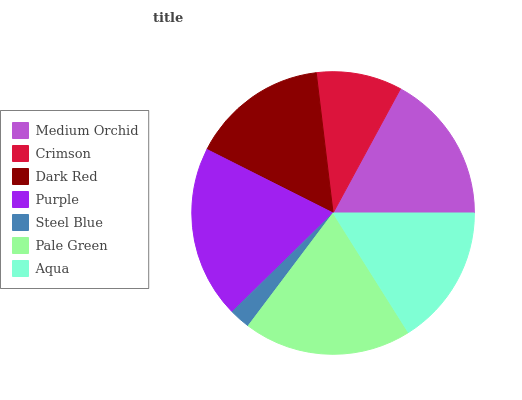Is Steel Blue the minimum?
Answer yes or no. Yes. Is Purple the maximum?
Answer yes or no. Yes. Is Crimson the minimum?
Answer yes or no. No. Is Crimson the maximum?
Answer yes or no. No. Is Medium Orchid greater than Crimson?
Answer yes or no. Yes. Is Crimson less than Medium Orchid?
Answer yes or no. Yes. Is Crimson greater than Medium Orchid?
Answer yes or no. No. Is Medium Orchid less than Crimson?
Answer yes or no. No. Is Aqua the high median?
Answer yes or no. Yes. Is Aqua the low median?
Answer yes or no. Yes. Is Purple the high median?
Answer yes or no. No. Is Crimson the low median?
Answer yes or no. No. 